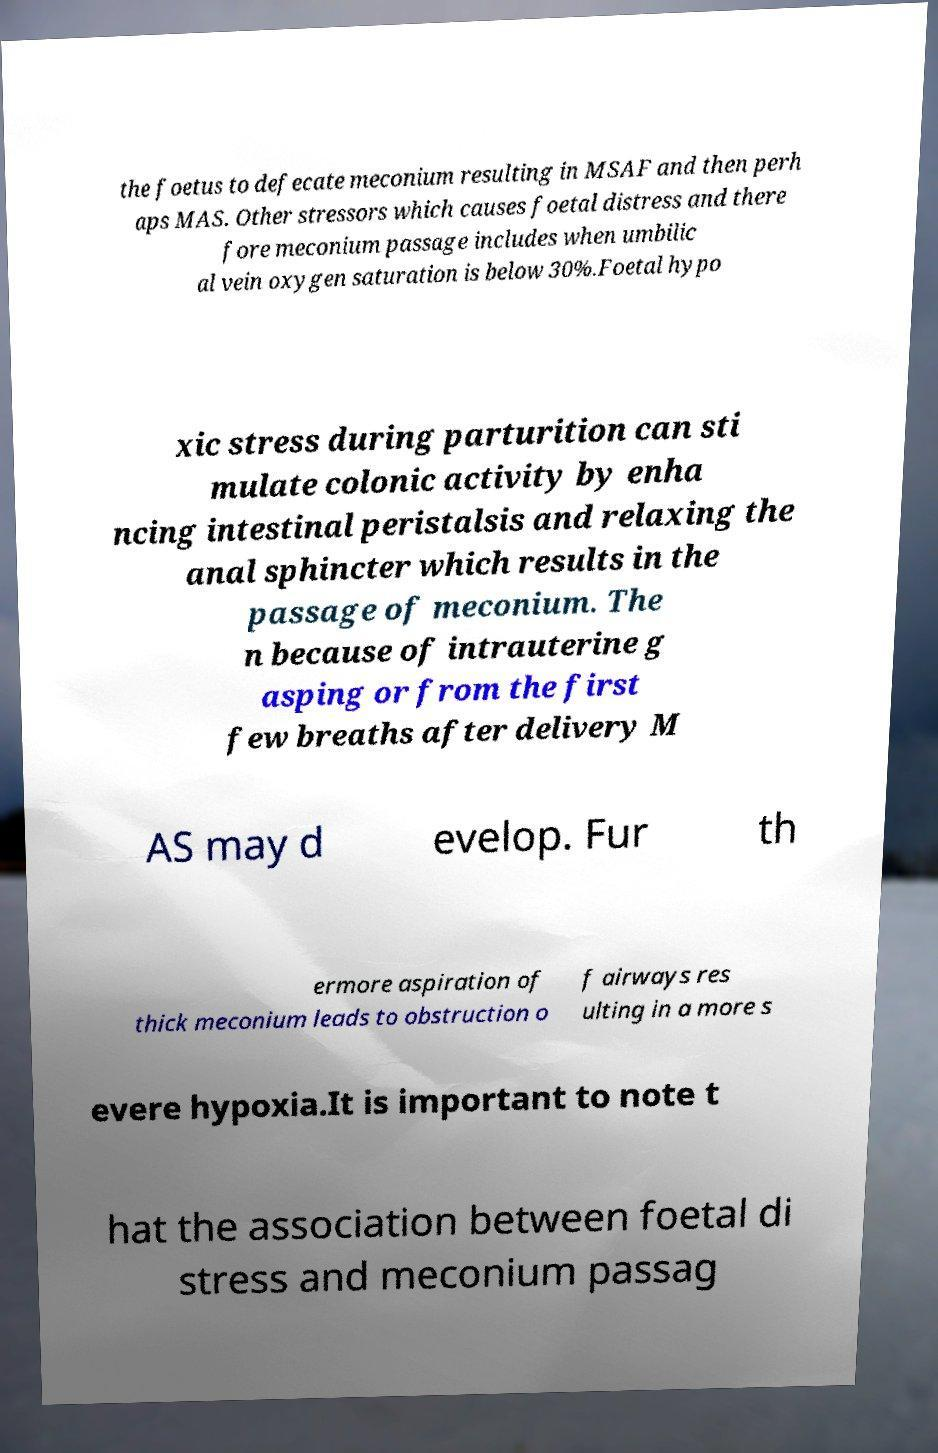I need the written content from this picture converted into text. Can you do that? the foetus to defecate meconium resulting in MSAF and then perh aps MAS. Other stressors which causes foetal distress and there fore meconium passage includes when umbilic al vein oxygen saturation is below 30%.Foetal hypo xic stress during parturition can sti mulate colonic activity by enha ncing intestinal peristalsis and relaxing the anal sphincter which results in the passage of meconium. The n because of intrauterine g asping or from the first few breaths after delivery M AS may d evelop. Fur th ermore aspiration of thick meconium leads to obstruction o f airways res ulting in a more s evere hypoxia.It is important to note t hat the association between foetal di stress and meconium passag 